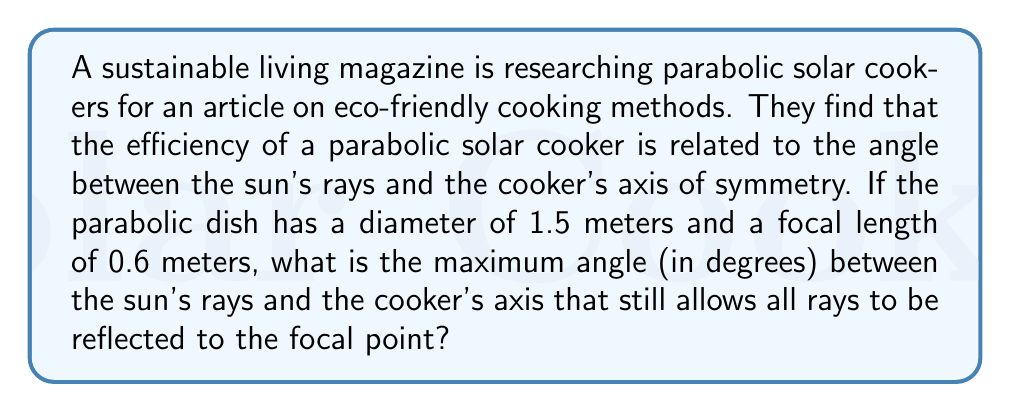Can you solve this math problem? To solve this problem, we need to consider the geometry of a parabolic reflector:

1) First, let's recall the equation of a parabola in the x-y plane:
   $$y = \frac{x^2}{4f}$$
   where $f$ is the focal length.

2) The diameter (D) of the dish is 1.5 meters, so its radius (r) is 0.75 meters.

3) We need to find the angle between the edge of the dish and the axis of symmetry. This angle is the same as the maximum angle between the sun's rays and the axis that still allows all rays to be reflected to the focal point.

4) At the edge of the dish, x = r = 0.75 m and f = 0.6 m. We can find y:
   $$y = \frac{(0.75)^2}{4(0.6)} = 0.234375 \text{ m}$$

5) Now we have a right triangle with:
   - Adjacent side = f = 0.6 m
   - Opposite side = y = 0.234375 m

6) We can use the arctangent function to find the angle:
   $$\theta = \arctan(\frac{y}{f}) = \arctan(\frac{0.234375}{0.6})$$

7) Calculate this value and convert to degrees:
   $$\theta = \arctan(0.390625) \approx 0.3724 \text{ radians}$$
   $$\theta \approx 21.33°$$

This angle represents the maximum deviation from the axis that still allows all rays to reach the focal point, ensuring maximum efficiency of the solar cooker.
Answer: The maximum angle is approximately 21.33°. 